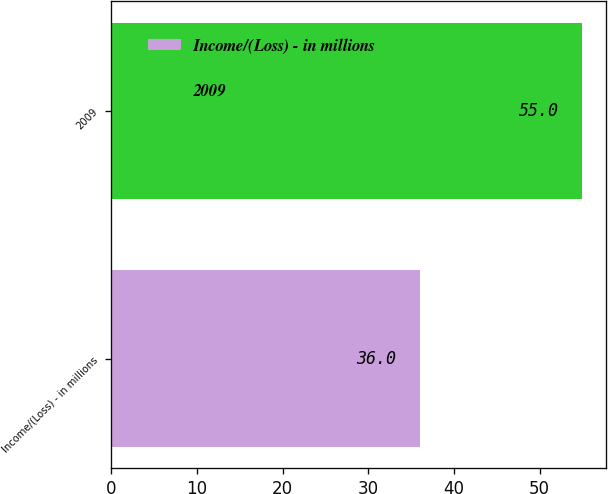Convert chart to OTSL. <chart><loc_0><loc_0><loc_500><loc_500><bar_chart><fcel>Income/(Loss) - in millions<fcel>2009<nl><fcel>36<fcel>55<nl></chart> 